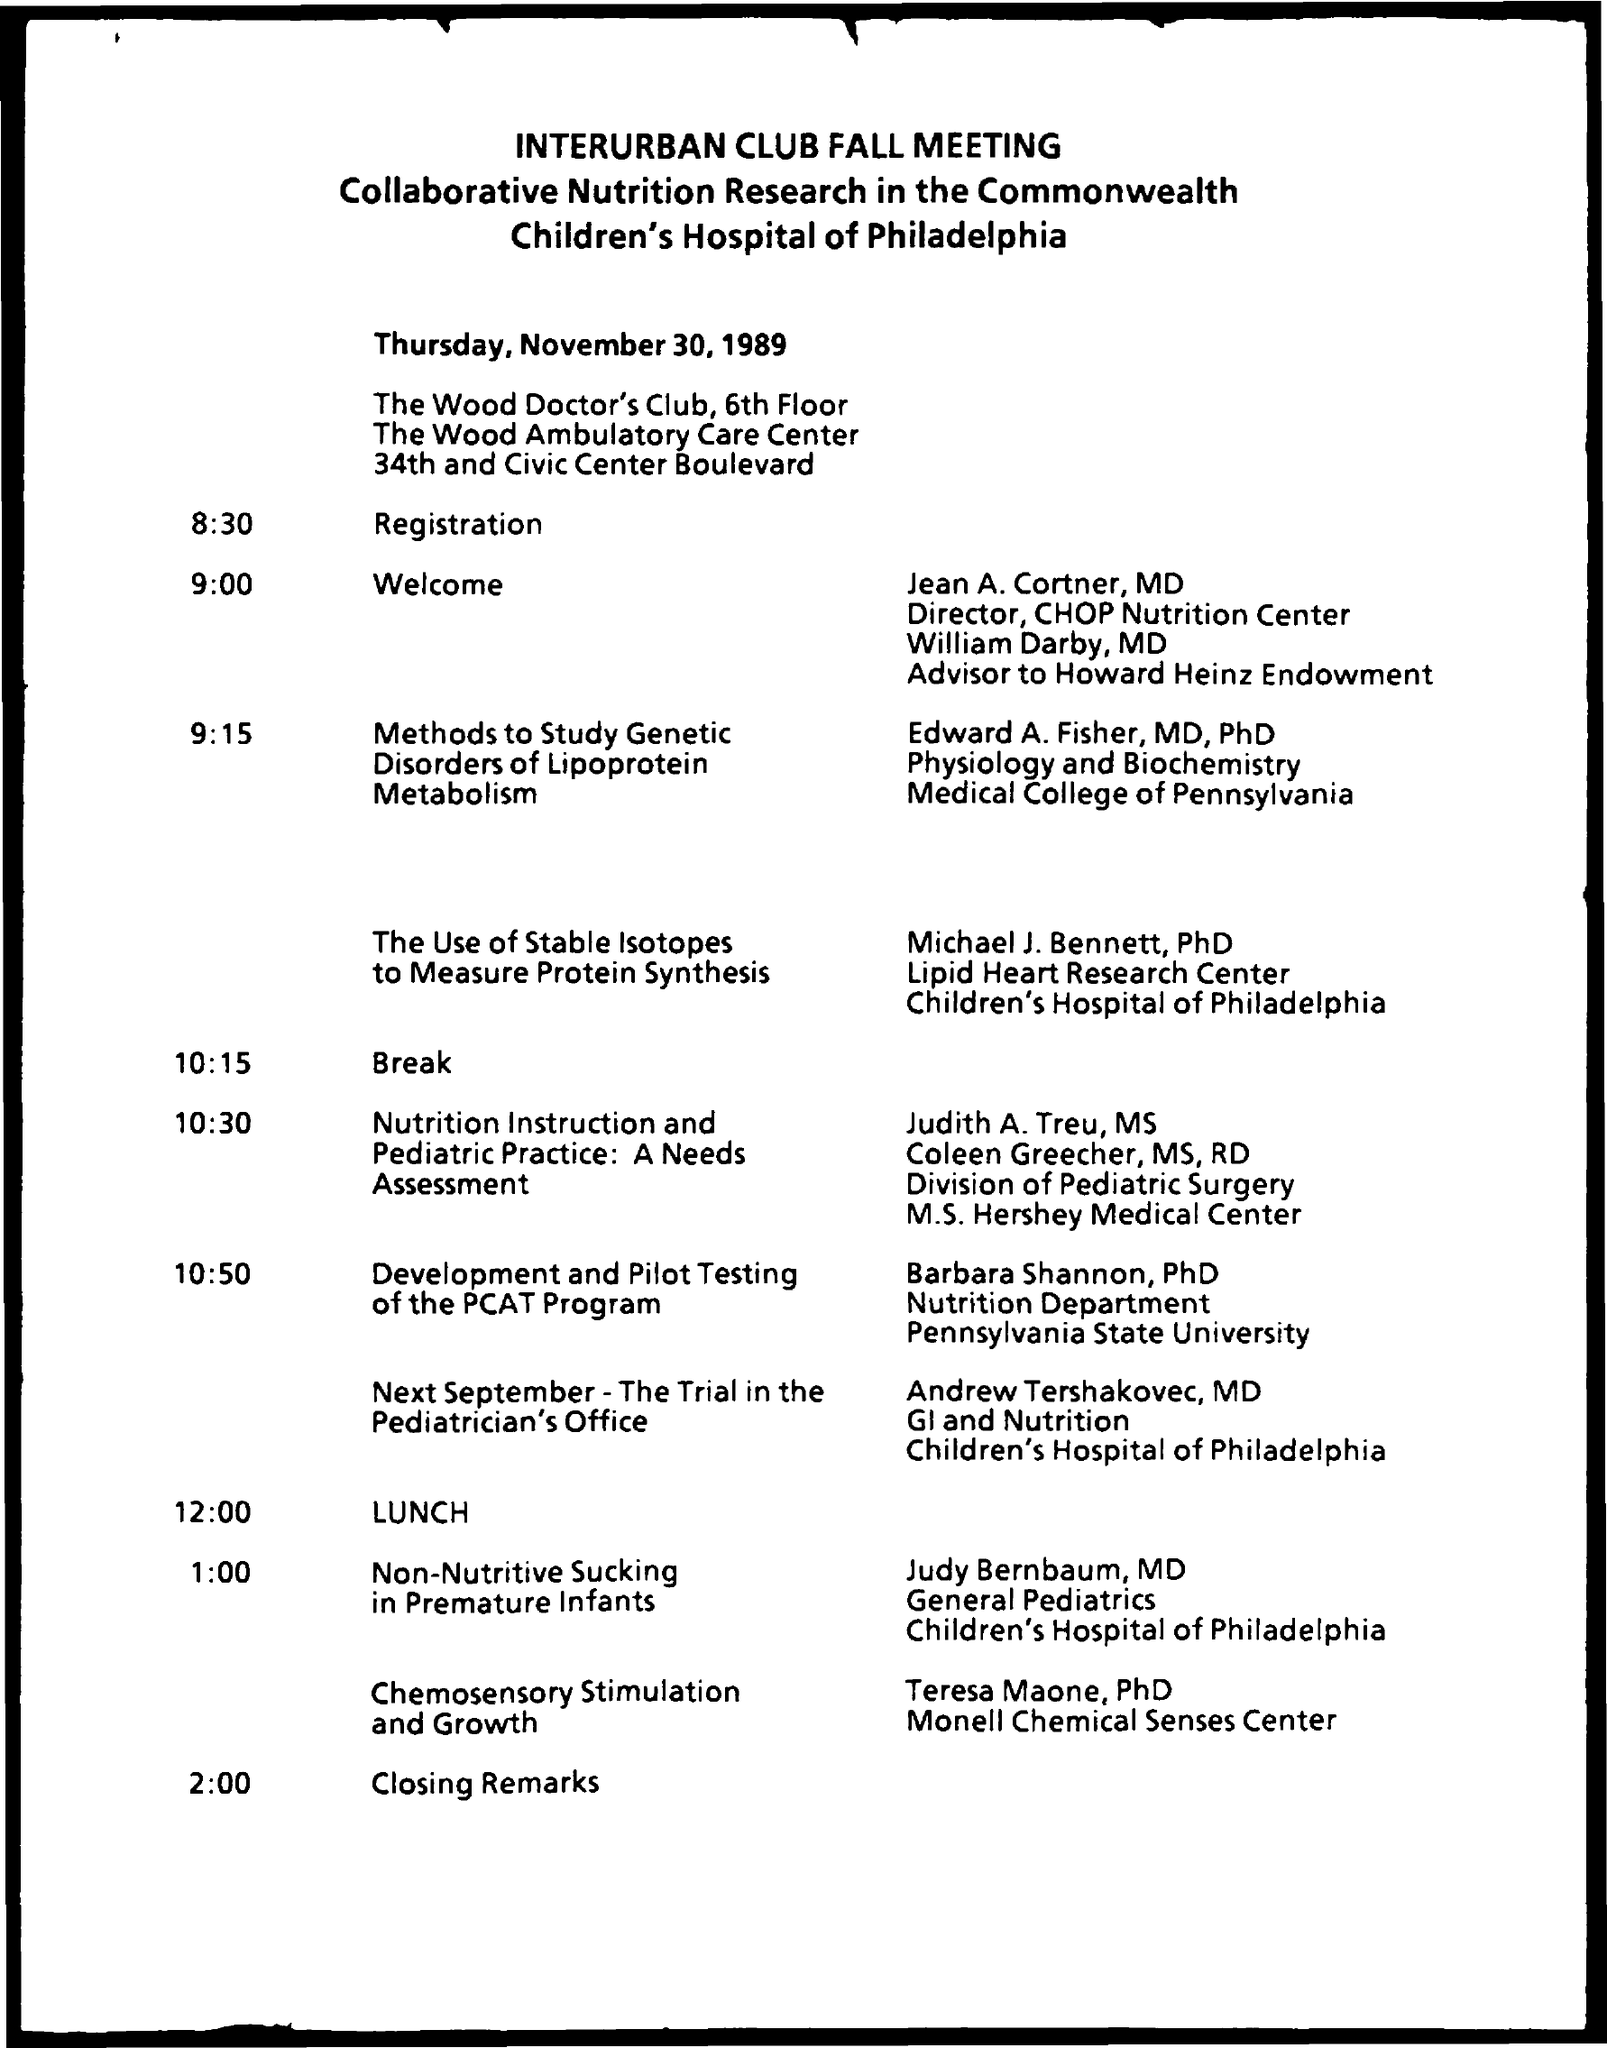Outline some significant characteristics in this image. At 9:00am, the given schedule is in effect. At the time of 10:15, the given schedule is. . . At 2:00 PM, the schedule is as follows: closing remarks. At 12:00 PM, the schedule is as follows: lunch will be served. The schedule is currently at 8:30 AM, and registration is taking place. 